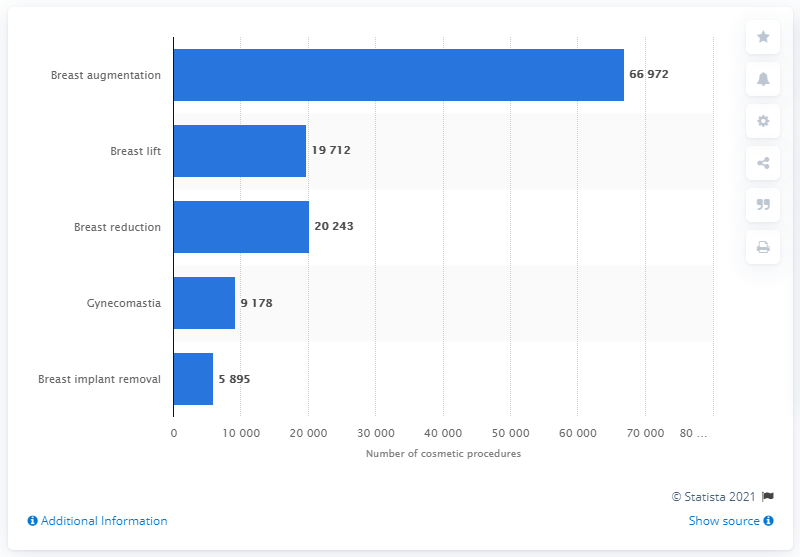List a handful of essential elements in this visual. In 2019, a total of 66,972 breast augmentation procedures were performed in Germany. 